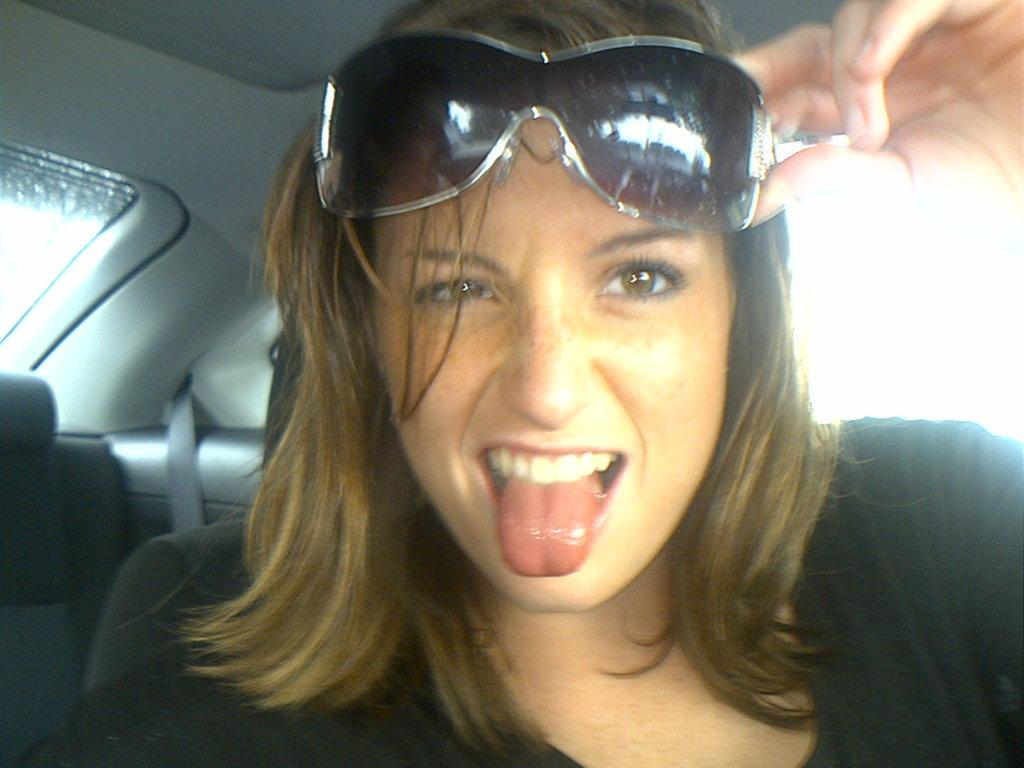What is the woman doing in the car? The woman is sitting in the seat. What is the woman wearing in the image? The woman is wearing goggles. How is the woman holding the goggles? The woman is holding the goggles with her hands. What shape is the light emitted by the goggles in the image? There is no light emitted by the goggles in the image, as they are simply being held by the woman. 